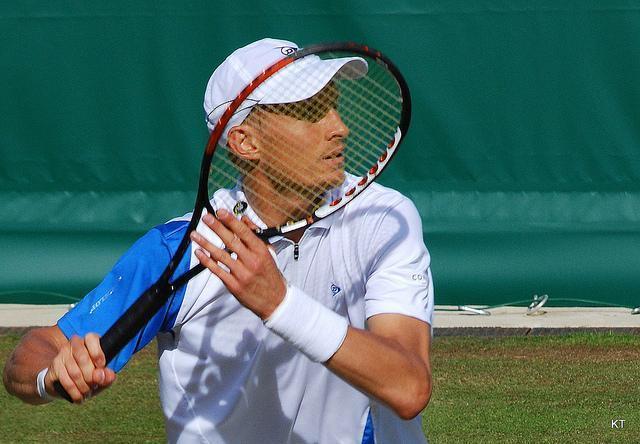Evaluate: Does the caption "The tennis racket is below the person." match the image?
Answer yes or no. No. 